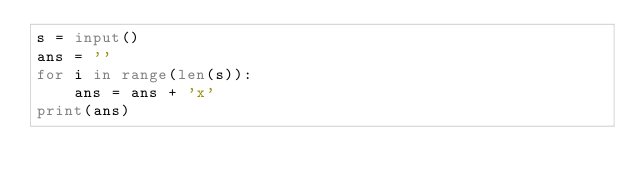Convert code to text. <code><loc_0><loc_0><loc_500><loc_500><_Python_>s = input()
ans = ''
for i in range(len(s)):
    ans = ans + 'x'
print(ans)</code> 